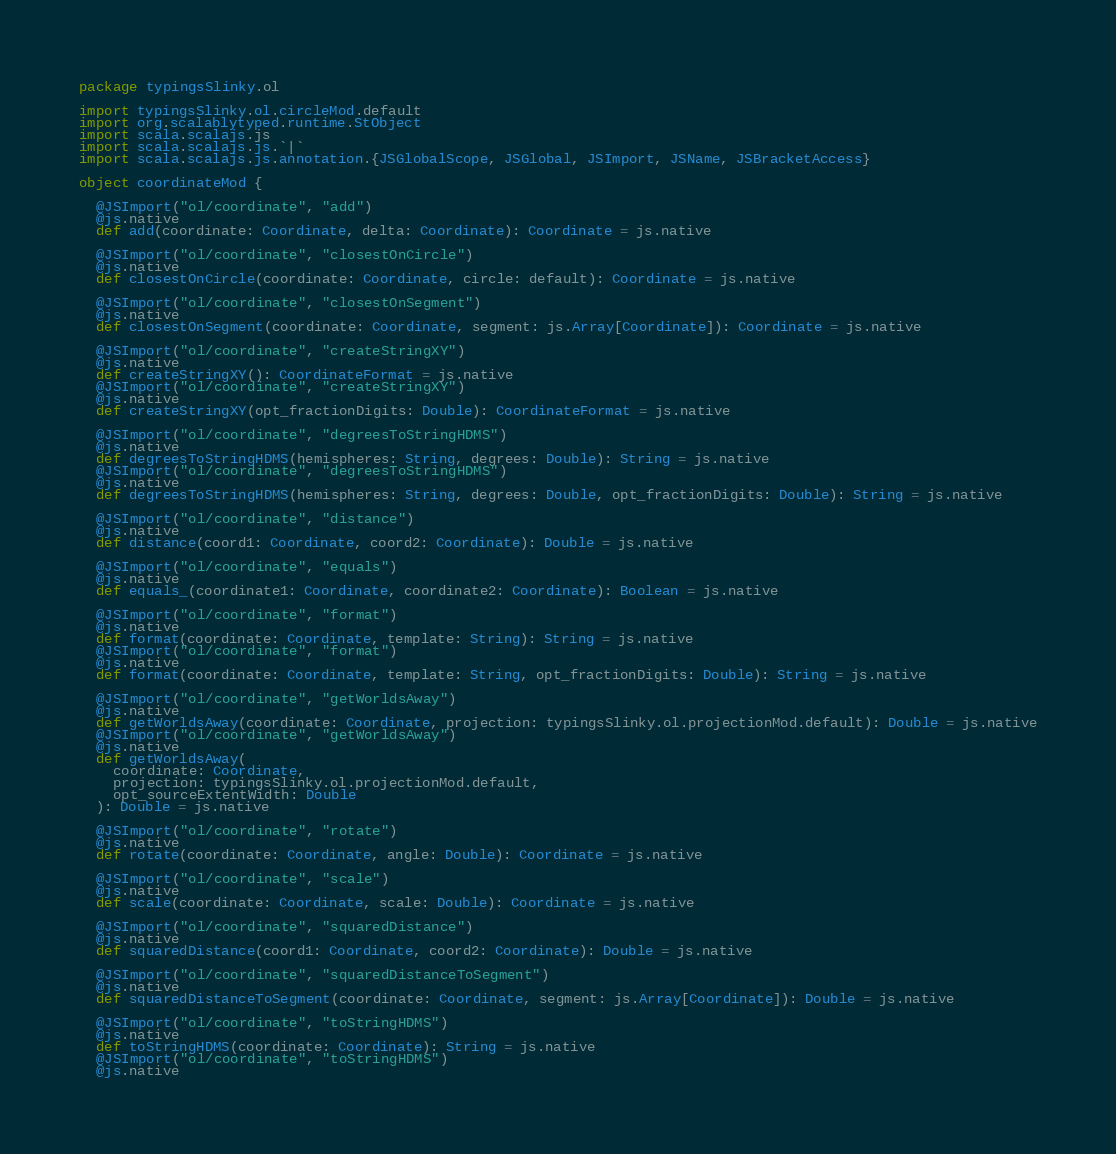Convert code to text. <code><loc_0><loc_0><loc_500><loc_500><_Scala_>package typingsSlinky.ol

import typingsSlinky.ol.circleMod.default
import org.scalablytyped.runtime.StObject
import scala.scalajs.js
import scala.scalajs.js.`|`
import scala.scalajs.js.annotation.{JSGlobalScope, JSGlobal, JSImport, JSName, JSBracketAccess}

object coordinateMod {
  
  @JSImport("ol/coordinate", "add")
  @js.native
  def add(coordinate: Coordinate, delta: Coordinate): Coordinate = js.native
  
  @JSImport("ol/coordinate", "closestOnCircle")
  @js.native
  def closestOnCircle(coordinate: Coordinate, circle: default): Coordinate = js.native
  
  @JSImport("ol/coordinate", "closestOnSegment")
  @js.native
  def closestOnSegment(coordinate: Coordinate, segment: js.Array[Coordinate]): Coordinate = js.native
  
  @JSImport("ol/coordinate", "createStringXY")
  @js.native
  def createStringXY(): CoordinateFormat = js.native
  @JSImport("ol/coordinate", "createStringXY")
  @js.native
  def createStringXY(opt_fractionDigits: Double): CoordinateFormat = js.native
  
  @JSImport("ol/coordinate", "degreesToStringHDMS")
  @js.native
  def degreesToStringHDMS(hemispheres: String, degrees: Double): String = js.native
  @JSImport("ol/coordinate", "degreesToStringHDMS")
  @js.native
  def degreesToStringHDMS(hemispheres: String, degrees: Double, opt_fractionDigits: Double): String = js.native
  
  @JSImport("ol/coordinate", "distance")
  @js.native
  def distance(coord1: Coordinate, coord2: Coordinate): Double = js.native
  
  @JSImport("ol/coordinate", "equals")
  @js.native
  def equals_(coordinate1: Coordinate, coordinate2: Coordinate): Boolean = js.native
  
  @JSImport("ol/coordinate", "format")
  @js.native
  def format(coordinate: Coordinate, template: String): String = js.native
  @JSImport("ol/coordinate", "format")
  @js.native
  def format(coordinate: Coordinate, template: String, opt_fractionDigits: Double): String = js.native
  
  @JSImport("ol/coordinate", "getWorldsAway")
  @js.native
  def getWorldsAway(coordinate: Coordinate, projection: typingsSlinky.ol.projectionMod.default): Double = js.native
  @JSImport("ol/coordinate", "getWorldsAway")
  @js.native
  def getWorldsAway(
    coordinate: Coordinate,
    projection: typingsSlinky.ol.projectionMod.default,
    opt_sourceExtentWidth: Double
  ): Double = js.native
  
  @JSImport("ol/coordinate", "rotate")
  @js.native
  def rotate(coordinate: Coordinate, angle: Double): Coordinate = js.native
  
  @JSImport("ol/coordinate", "scale")
  @js.native
  def scale(coordinate: Coordinate, scale: Double): Coordinate = js.native
  
  @JSImport("ol/coordinate", "squaredDistance")
  @js.native
  def squaredDistance(coord1: Coordinate, coord2: Coordinate): Double = js.native
  
  @JSImport("ol/coordinate", "squaredDistanceToSegment")
  @js.native
  def squaredDistanceToSegment(coordinate: Coordinate, segment: js.Array[Coordinate]): Double = js.native
  
  @JSImport("ol/coordinate", "toStringHDMS")
  @js.native
  def toStringHDMS(coordinate: Coordinate): String = js.native
  @JSImport("ol/coordinate", "toStringHDMS")
  @js.native</code> 